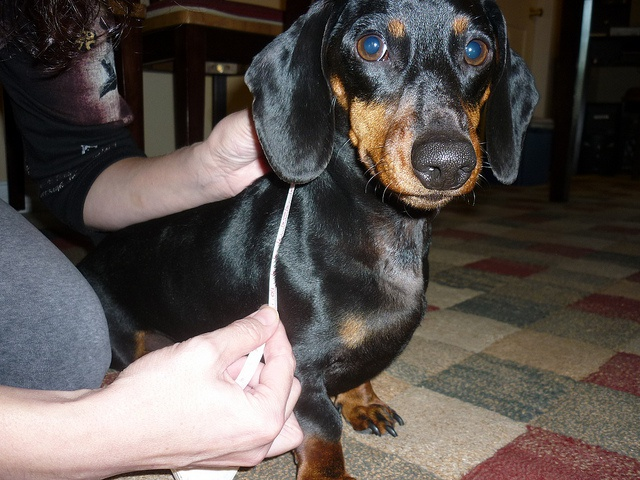Describe the objects in this image and their specific colors. I can see dog in black, gray, darkgray, and maroon tones, people in black, white, gray, and darkgray tones, and chair in black, maroon, and gray tones in this image. 